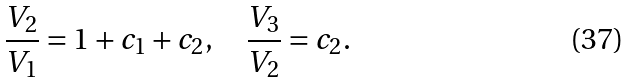Convert formula to latex. <formula><loc_0><loc_0><loc_500><loc_500>\frac { V _ { 2 } } { V _ { 1 } } = 1 + c _ { 1 } + c _ { 2 } , \quad \frac { V _ { 3 } } { V _ { 2 } } = c _ { 2 } .</formula> 